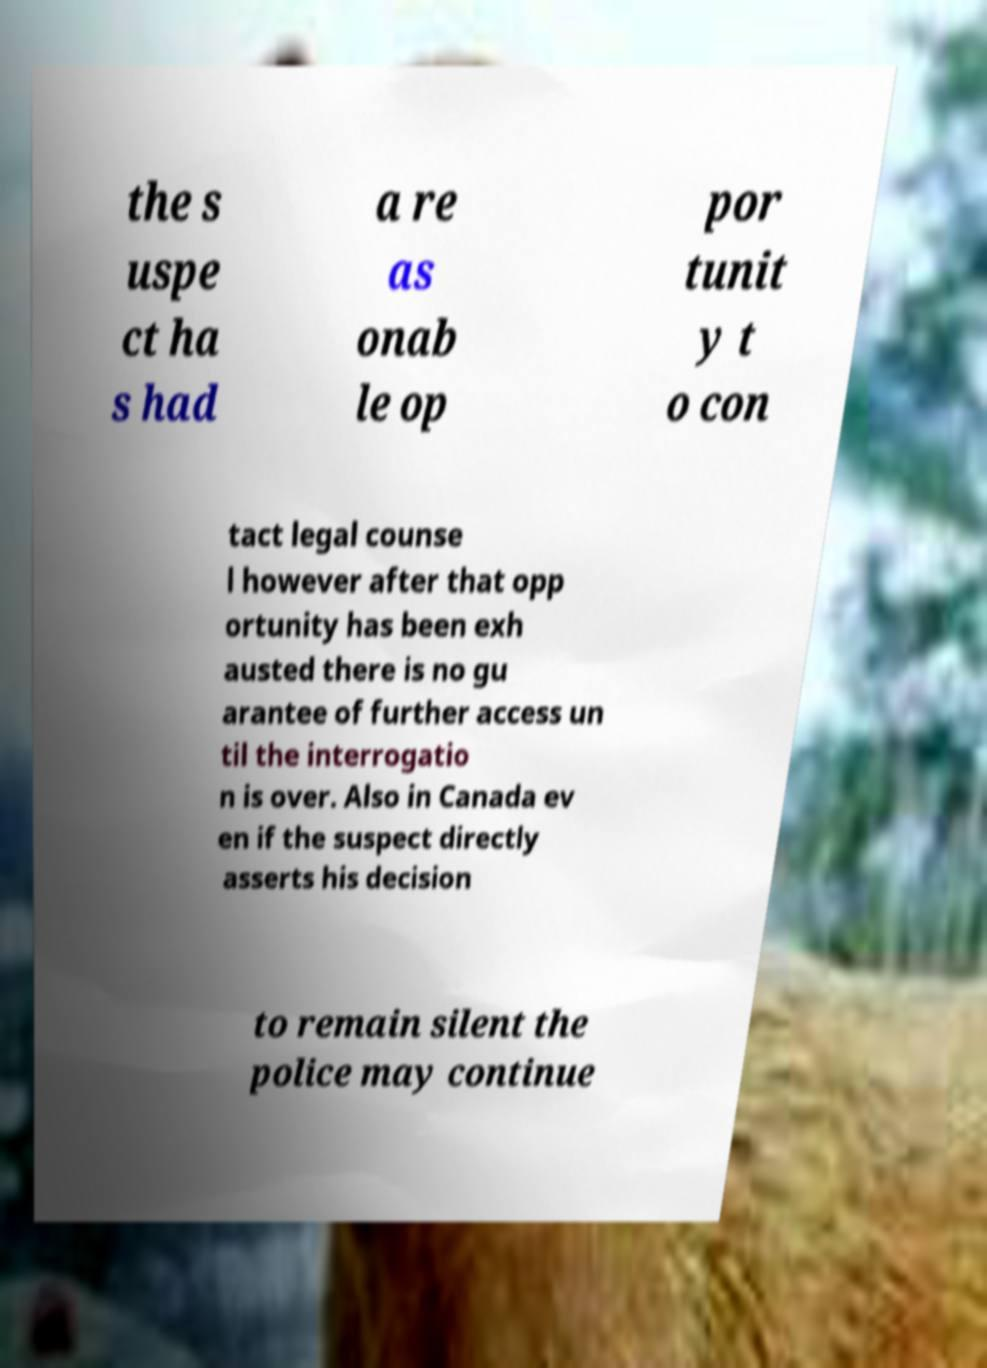Could you assist in decoding the text presented in this image and type it out clearly? the s uspe ct ha s had a re as onab le op por tunit y t o con tact legal counse l however after that opp ortunity has been exh austed there is no gu arantee of further access un til the interrogatio n is over. Also in Canada ev en if the suspect directly asserts his decision to remain silent the police may continue 